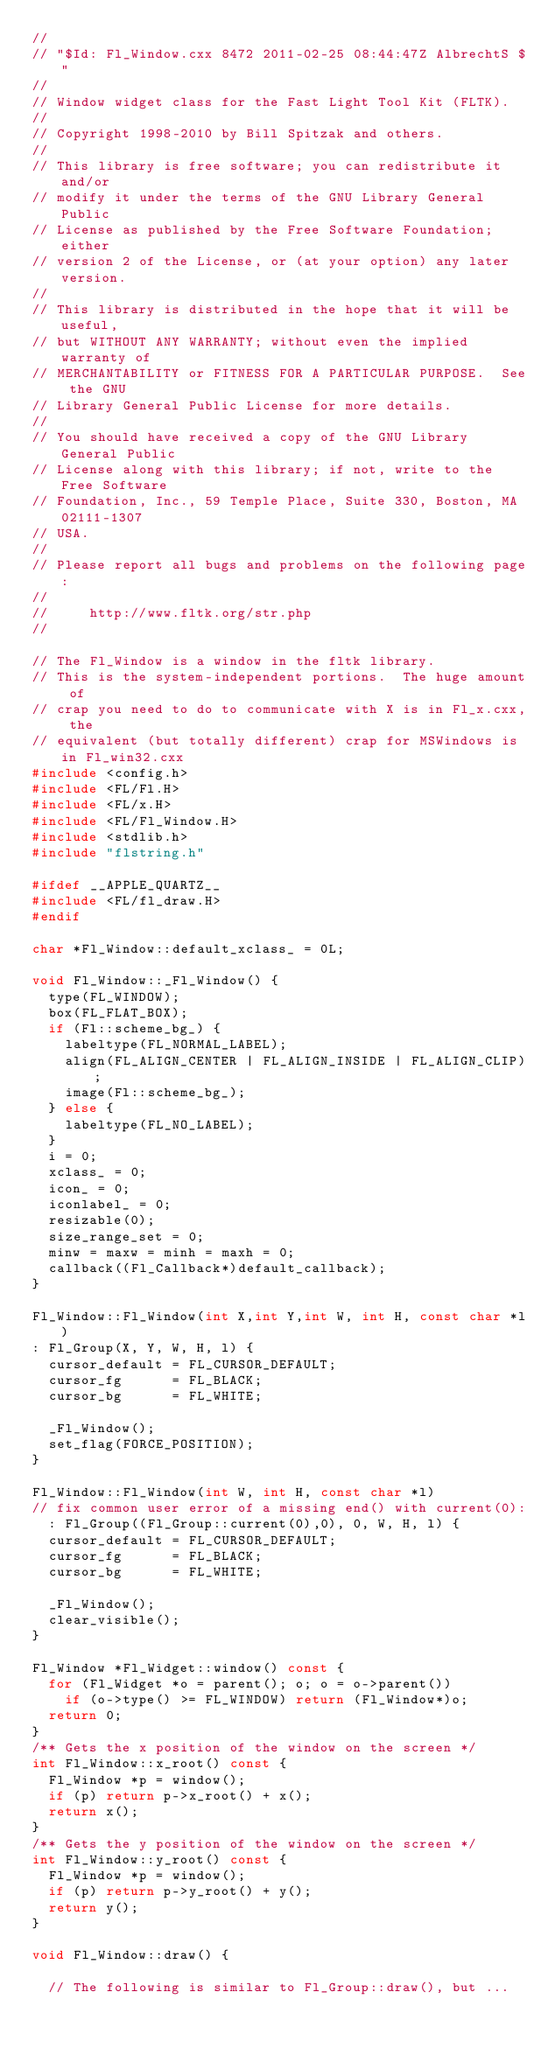<code> <loc_0><loc_0><loc_500><loc_500><_C++_>//
// "$Id: Fl_Window.cxx 8472 2011-02-25 08:44:47Z AlbrechtS $"
//
// Window widget class for the Fast Light Tool Kit (FLTK).
//
// Copyright 1998-2010 by Bill Spitzak and others.
//
// This library is free software; you can redistribute it and/or
// modify it under the terms of the GNU Library General Public
// License as published by the Free Software Foundation; either
// version 2 of the License, or (at your option) any later version.
//
// This library is distributed in the hope that it will be useful,
// but WITHOUT ANY WARRANTY; without even the implied warranty of
// MERCHANTABILITY or FITNESS FOR A PARTICULAR PURPOSE.  See the GNU
// Library General Public License for more details.
//
// You should have received a copy of the GNU Library General Public
// License along with this library; if not, write to the Free Software
// Foundation, Inc., 59 Temple Place, Suite 330, Boston, MA 02111-1307
// USA.
//
// Please report all bugs and problems on the following page:
//
//     http://www.fltk.org/str.php
//

// The Fl_Window is a window in the fltk library.
// This is the system-independent portions.  The huge amount of 
// crap you need to do to communicate with X is in Fl_x.cxx, the
// equivalent (but totally different) crap for MSWindows is in Fl_win32.cxx
#include <config.h>
#include <FL/Fl.H>
#include <FL/x.H>
#include <FL/Fl_Window.H>
#include <stdlib.h>
#include "flstring.h"

#ifdef __APPLE_QUARTZ__
#include <FL/fl_draw.H>
#endif

char *Fl_Window::default_xclass_ = 0L;

void Fl_Window::_Fl_Window() {
  type(FL_WINDOW);
  box(FL_FLAT_BOX);
  if (Fl::scheme_bg_) {
    labeltype(FL_NORMAL_LABEL);
    align(FL_ALIGN_CENTER | FL_ALIGN_INSIDE | FL_ALIGN_CLIP);
    image(Fl::scheme_bg_);
  } else {
    labeltype(FL_NO_LABEL);
  }
  i = 0;
  xclass_ = 0;
  icon_ = 0;
  iconlabel_ = 0;
  resizable(0);
  size_range_set = 0;
  minw = maxw = minh = maxh = 0;
  callback((Fl_Callback*)default_callback);
}

Fl_Window::Fl_Window(int X,int Y,int W, int H, const char *l)
: Fl_Group(X, Y, W, H, l) {
  cursor_default = FL_CURSOR_DEFAULT;
  cursor_fg      = FL_BLACK;
  cursor_bg      = FL_WHITE;

  _Fl_Window();
  set_flag(FORCE_POSITION);
}

Fl_Window::Fl_Window(int W, int H, const char *l)
// fix common user error of a missing end() with current(0):
  : Fl_Group((Fl_Group::current(0),0), 0, W, H, l) {
  cursor_default = FL_CURSOR_DEFAULT;
  cursor_fg      = FL_BLACK;
  cursor_bg      = FL_WHITE;

  _Fl_Window();
  clear_visible();
}

Fl_Window *Fl_Widget::window() const {
  for (Fl_Widget *o = parent(); o; o = o->parent())
    if (o->type() >= FL_WINDOW) return (Fl_Window*)o;
  return 0;
}
/** Gets the x position of the window on the screen */
int Fl_Window::x_root() const {
  Fl_Window *p = window();
  if (p) return p->x_root() + x();
  return x();
}
/** Gets the y position of the window on the screen */
int Fl_Window::y_root() const {
  Fl_Window *p = window();
  if (p) return p->y_root() + y();
  return y();
}

void Fl_Window::draw() {

  // The following is similar to Fl_Group::draw(), but ...</code> 